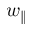<formula> <loc_0><loc_0><loc_500><loc_500>w _ { \| }</formula> 